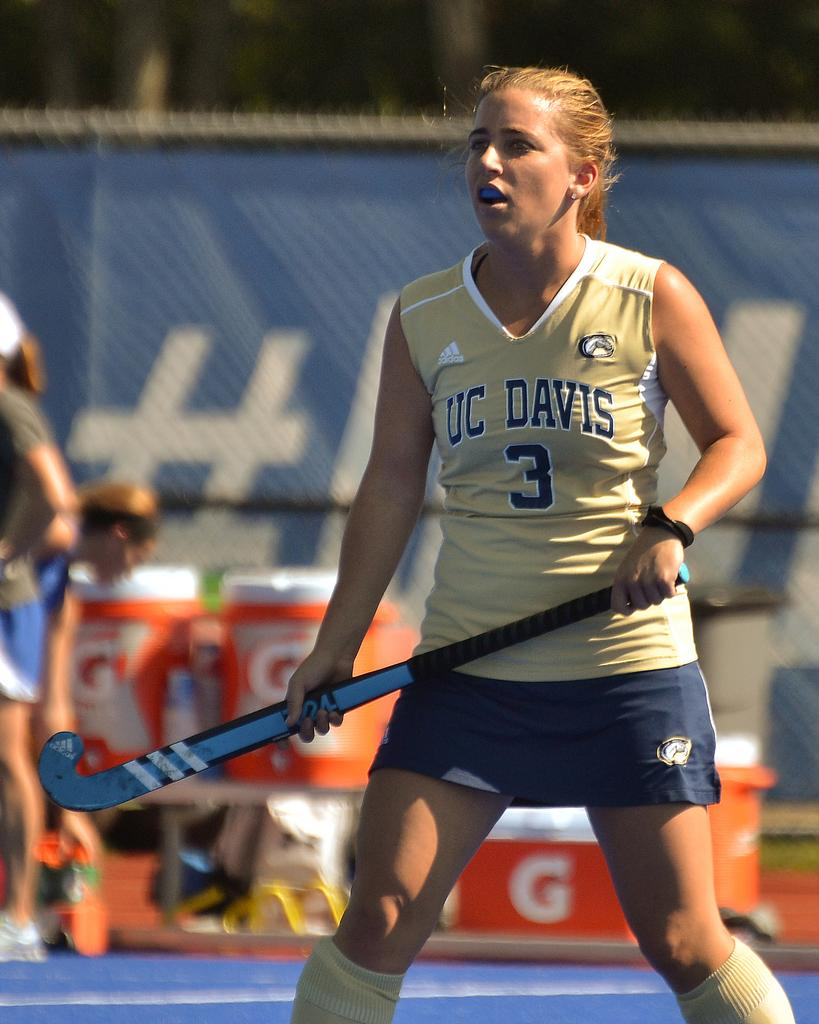<image>
Render a clear and concise summary of the photo. a girl with the number 3 on her field hockey jersey 